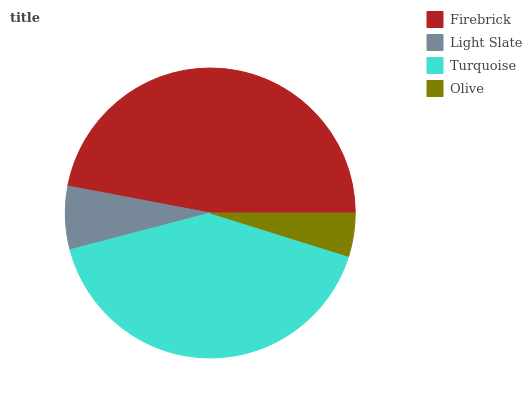Is Olive the minimum?
Answer yes or no. Yes. Is Firebrick the maximum?
Answer yes or no. Yes. Is Light Slate the minimum?
Answer yes or no. No. Is Light Slate the maximum?
Answer yes or no. No. Is Firebrick greater than Light Slate?
Answer yes or no. Yes. Is Light Slate less than Firebrick?
Answer yes or no. Yes. Is Light Slate greater than Firebrick?
Answer yes or no. No. Is Firebrick less than Light Slate?
Answer yes or no. No. Is Turquoise the high median?
Answer yes or no. Yes. Is Light Slate the low median?
Answer yes or no. Yes. Is Olive the high median?
Answer yes or no. No. Is Turquoise the low median?
Answer yes or no. No. 